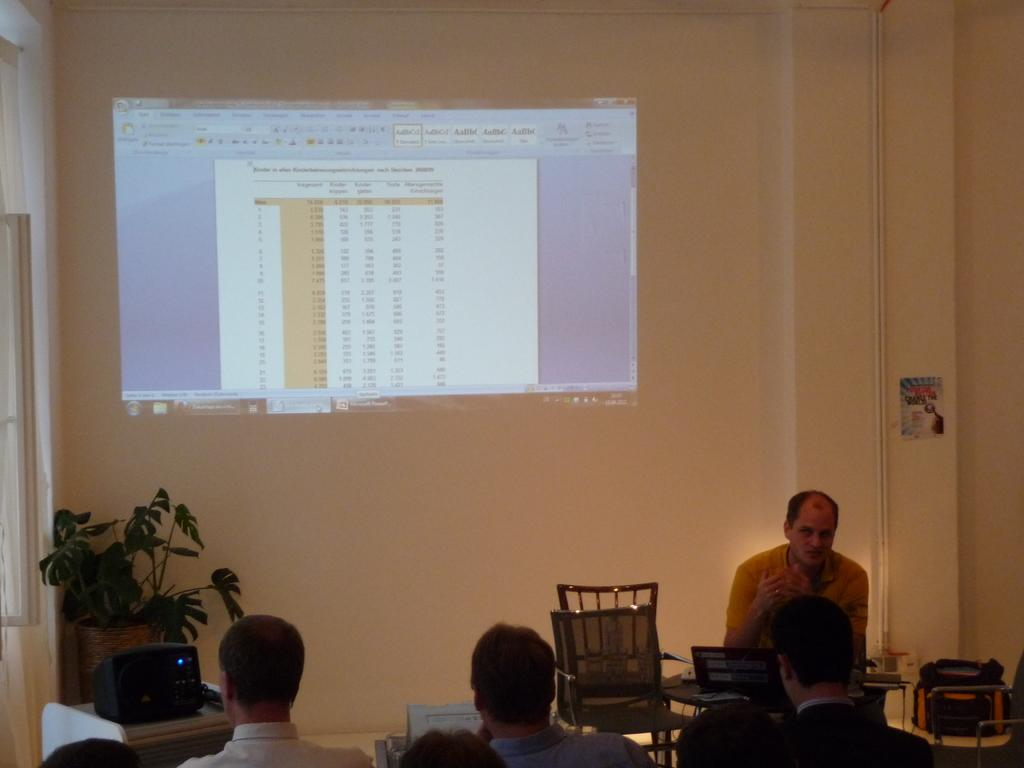What type of setting is shown in the image? The image depicts a room. What is being displayed on the wall in the room? A presentation is being displayed on the wall. What are the people in the room doing? There are people sitting and watching the presentation. What color is the wall on which the presentation is displayed? The wall is of cream color. Can you see the grandfather in the image? There is no mention of a grandfather in the image. 